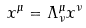<formula> <loc_0><loc_0><loc_500><loc_500>x ^ { \mu } = \Lambda ^ { \mu } _ { \nu } x ^ { \nu }</formula> 